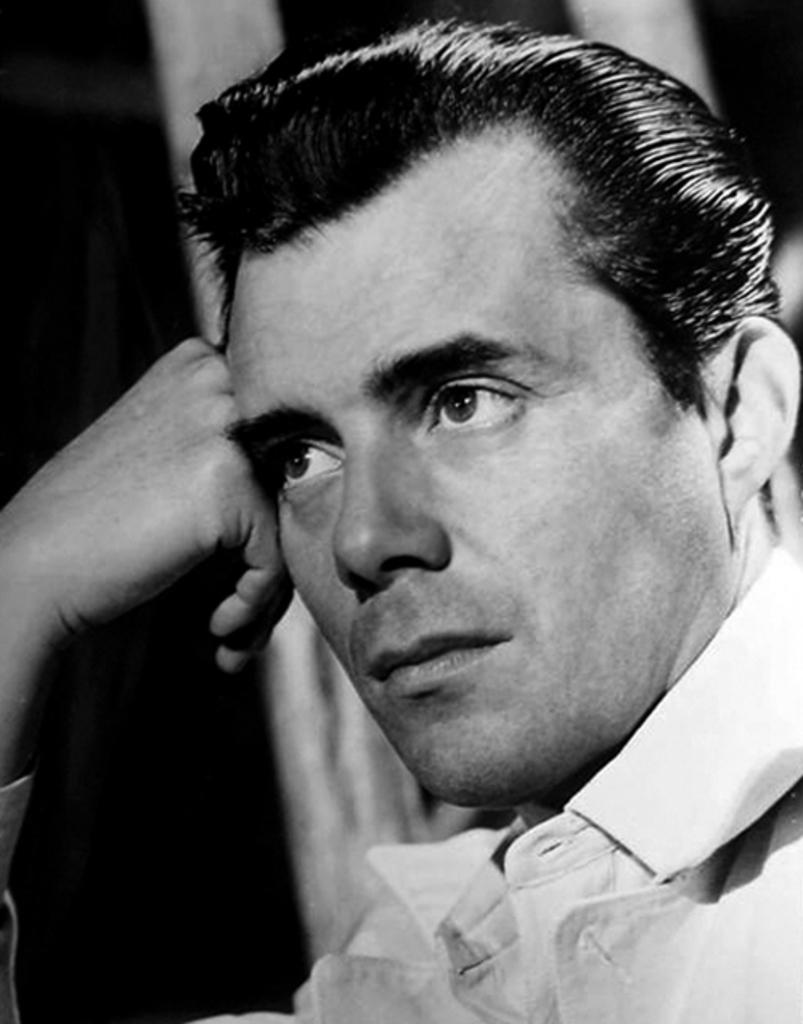Who is present in the image? There is a man in the image. What is the man wearing? The man is wearing a shirt. What type of material is the wall made of in the image? There is a wooden wall in the image. What type of system is being discussed in the meeting in the image? There is no meeting or system present in the image; it only features a man and a wooden wall. 